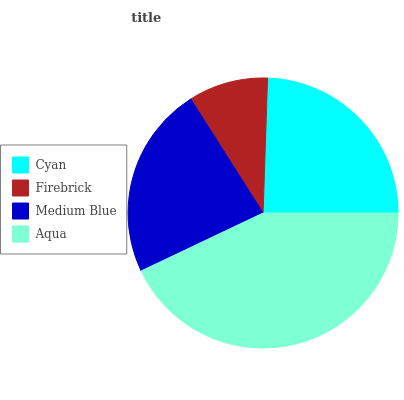Is Firebrick the minimum?
Answer yes or no. Yes. Is Aqua the maximum?
Answer yes or no. Yes. Is Medium Blue the minimum?
Answer yes or no. No. Is Medium Blue the maximum?
Answer yes or no. No. Is Medium Blue greater than Firebrick?
Answer yes or no. Yes. Is Firebrick less than Medium Blue?
Answer yes or no. Yes. Is Firebrick greater than Medium Blue?
Answer yes or no. No. Is Medium Blue less than Firebrick?
Answer yes or no. No. Is Cyan the high median?
Answer yes or no. Yes. Is Medium Blue the low median?
Answer yes or no. Yes. Is Firebrick the high median?
Answer yes or no. No. Is Firebrick the low median?
Answer yes or no. No. 